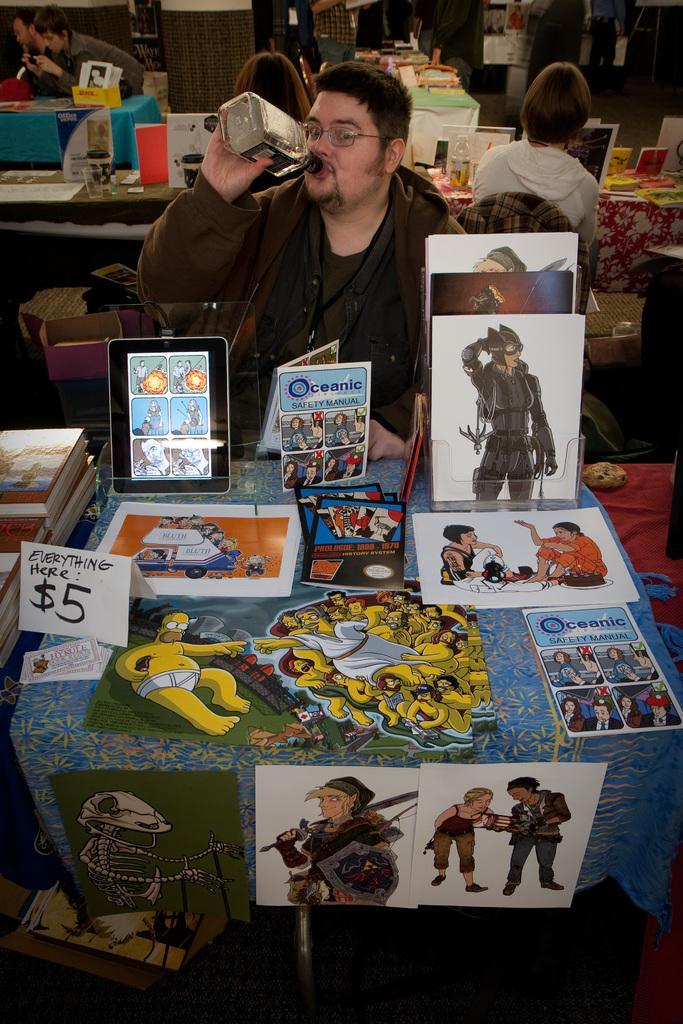How would you summarize this image in a sentence or two? In this picture we can see a group of people sitting on chairs and a man is holding a bottle and drinking some liquid. In front of the people there are tables and on the table there are books, paper, tablet and other things. 